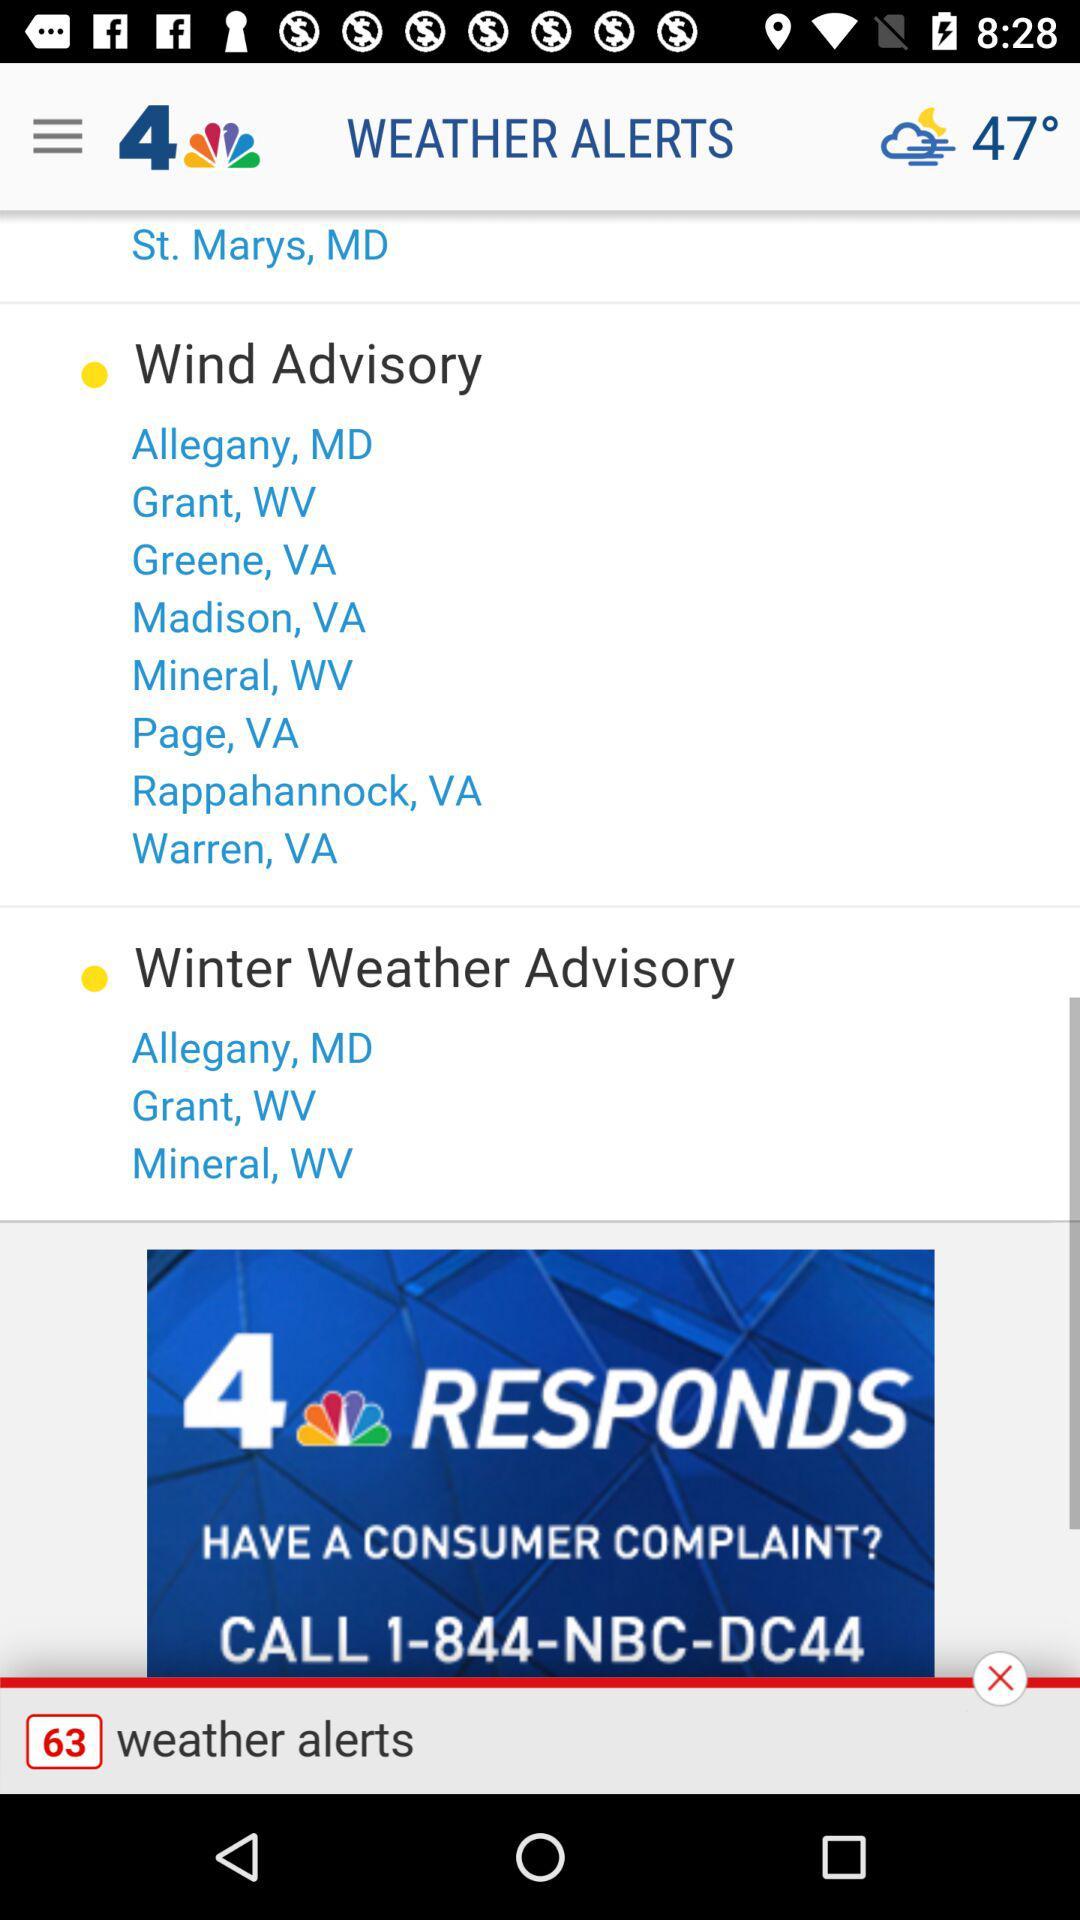What is the temperature? The temperature is 47°. 